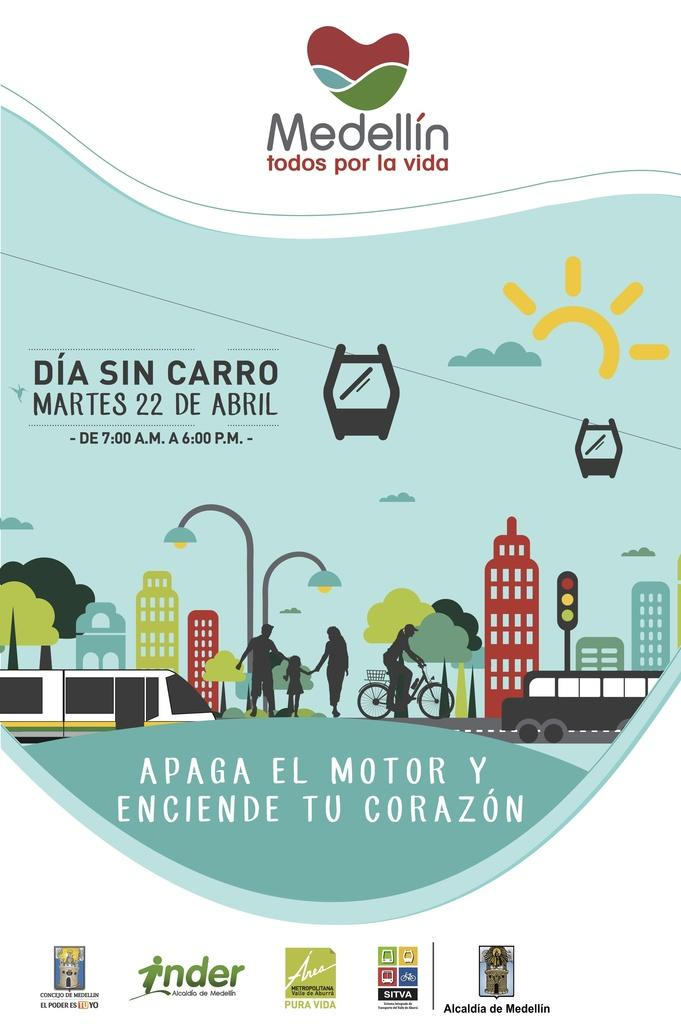<image>
Describe the image concisely. An event is scheduled on Martes 22 de Abril. 